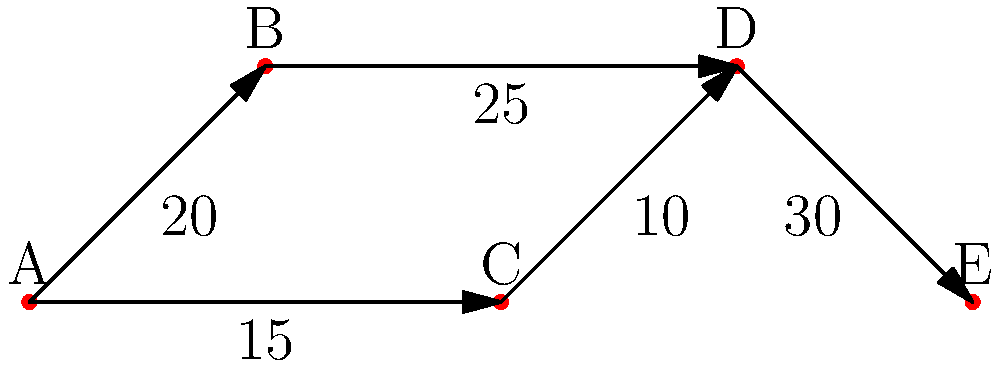The network diagram represents trade routes between five cities (A, B, C, D, and E) with the numbers indicating the volume of goods (in tons) flowing along each route. What is the maximum volume of goods that can be transported from city A to city E? To find the maximum volume of goods that can be transported from city A to city E, we need to identify all possible paths and determine the path with the highest capacity. Let's break it down step-by-step:

1. Identify all possible paths from A to E:
   Path 1: A → B → D → E
   Path 2: A → C → D → E

2. Calculate the capacity of each path:
   Path 1: A → B → D → E
   Capacity = min(20, 25, 30) = 20 tons
   
   Path 2: A → C → D → E
   Capacity = min(15, 10, 30) = 10 tons

3. Compare the capacities:
   Path 1 has a capacity of 20 tons
   Path 2 has a capacity of 10 tons

4. Choose the path with the maximum capacity:
   The maximum capacity is 20 tons, which is achieved through Path 1 (A → B → D → E)

Therefore, the maximum volume of goods that can be transported from city A to city E is 20 tons.
Answer: 20 tons 